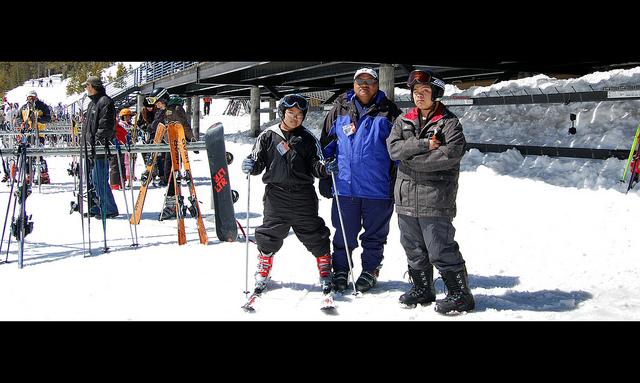What sport do they do?
Give a very brief answer. Skiing. Is it cold?
Keep it brief. Yes. How many of the three people are wearing skis?
Keep it brief. 1. 